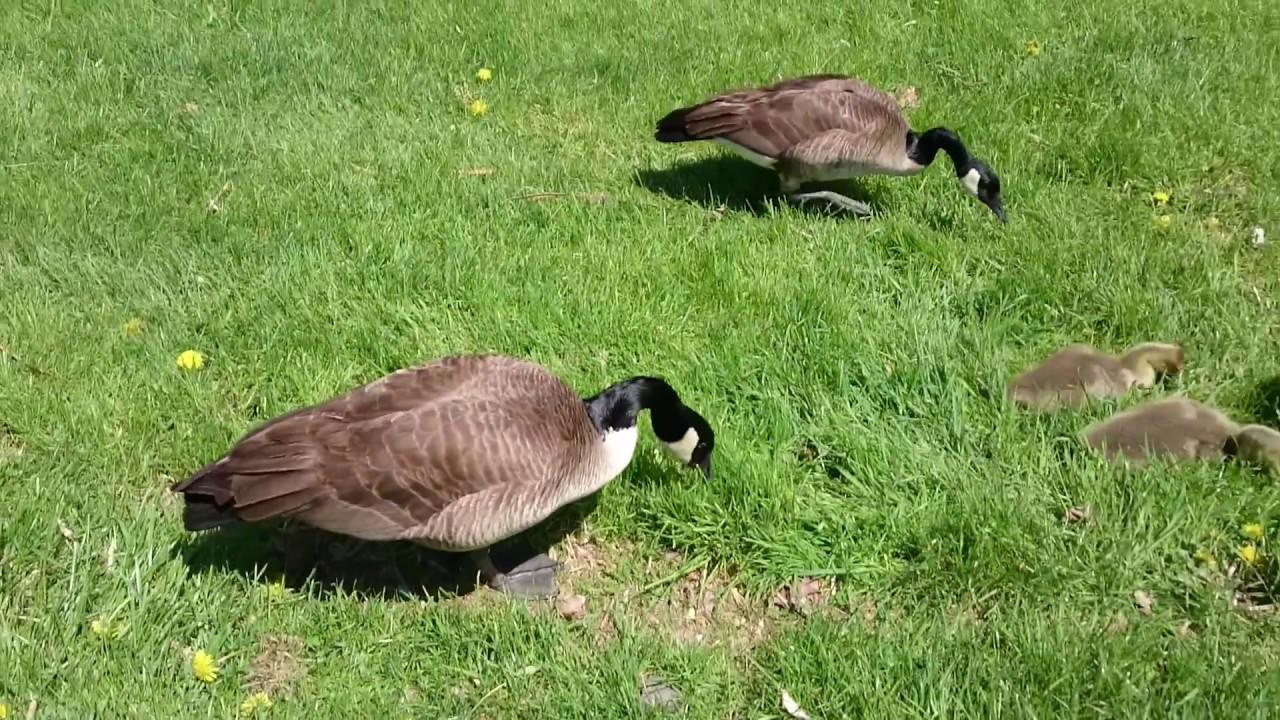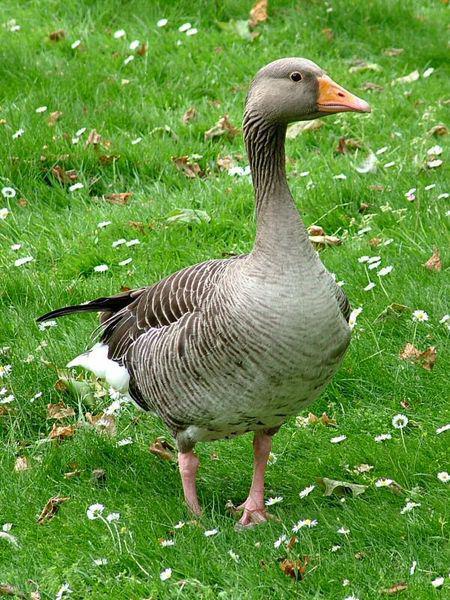The first image is the image on the left, the second image is the image on the right. Given the left and right images, does the statement "One of the images features a single goose with an orange beak." hold true? Answer yes or no. Yes. The first image is the image on the left, the second image is the image on the right. For the images displayed, is the sentence "One image contains one grey goose with a grey neck who is standing upright with tucked wings, and the other image includes exactly two black necked geese with at least one bending its neck to the grass." factually correct? Answer yes or no. Yes. 